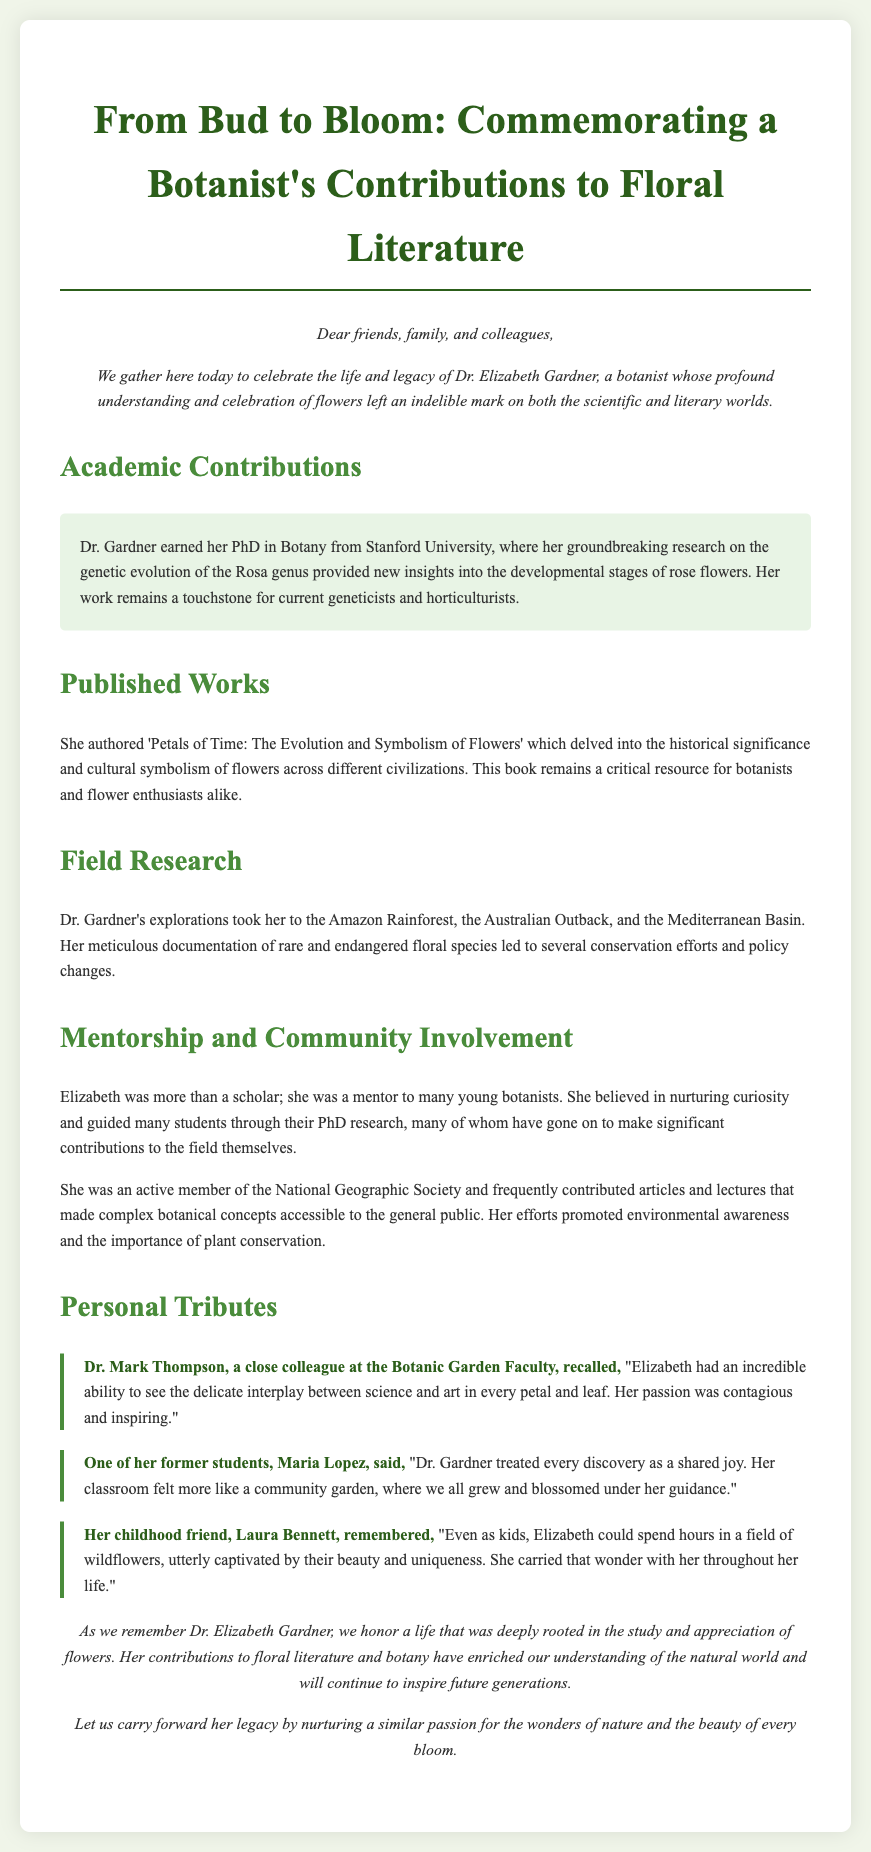What was Dr. Elizabeth Gardner's PhD institution? The document states that Dr. Gardner earned her PhD in Botany from Stanford University.
Answer: Stanford University What is the title of Dr. Gardner's noteworthy book? The book authored by Dr. Gardner is titled 'Petals of Time: The Evolution and Symbolism of Flowers'.
Answer: Petals of Time: The Evolution and Symbolism of Flowers Which regions did Dr. Gardner conduct her field research? The document indicates that her explorations took her to the Amazon Rainforest, the Australian Outback, and the Mediterranean Basin.
Answer: Amazon Rainforest, Australian Outback, Mediterranean Basin Who praised Dr. Gardner for her ability to blend science and art? Dr. Mark Thompson, a colleague, is noted for recalling Elizabeth's ability to see the delicate interplay between science and art in flowers.
Answer: Dr. Mark Thompson What role did Dr. Gardner play as a mentor? The document mentions that she was a mentor to many young botanists and guided them through their PhD research.
Answer: Mentor to many young botanists What did Dr. Gardner's research focus on? Dr. Gardner's research focused on the genetic evolution of the Rosa genus, providing insights into the developmental stages of rose flowers.
Answer: Genetic evolution of the Rosa genus What kind of articles and contributions did Dr. Gardner make to the National Geographic Society? She contributed articles and lectures that made complex botanical concepts accessible to the general public.
Answer: Accessible articles and lectures What is emphasized as part of Dr. Gardner's legacy? The conclusion highlights that her contributions to floral literature and botany enriched our understanding of the natural world.
Answer: Enrichment of our understanding of the natural world 